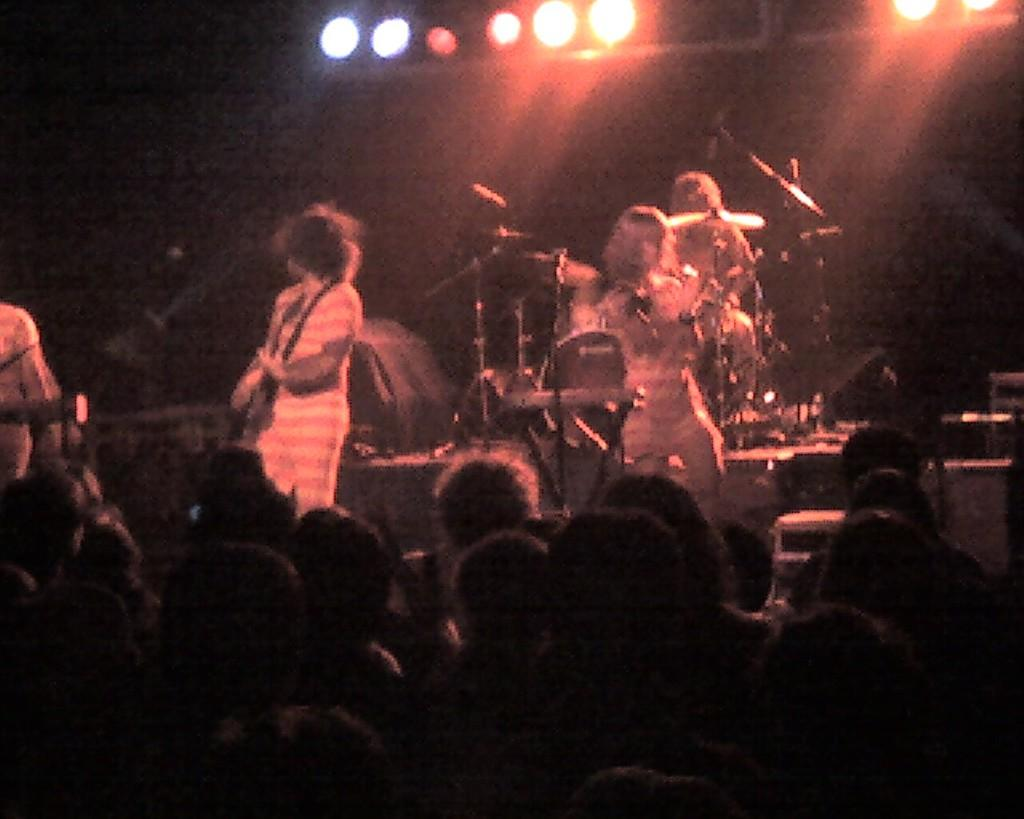What can be seen at the top of the image? There are lights visible at the top of the image. How would you describe the overall lighting in the image? The background of the image is dark. What are the persons in the image doing? They are playing musical instruments. Can you describe the audience in the image? There is a crowd visible in the image. What type of toy can be seen rolling on the ground in the image? There is no toy present in the image; it features persons playing musical instruments and a crowd. How many clovers are visible in the image? There are no clovers present in the image. 